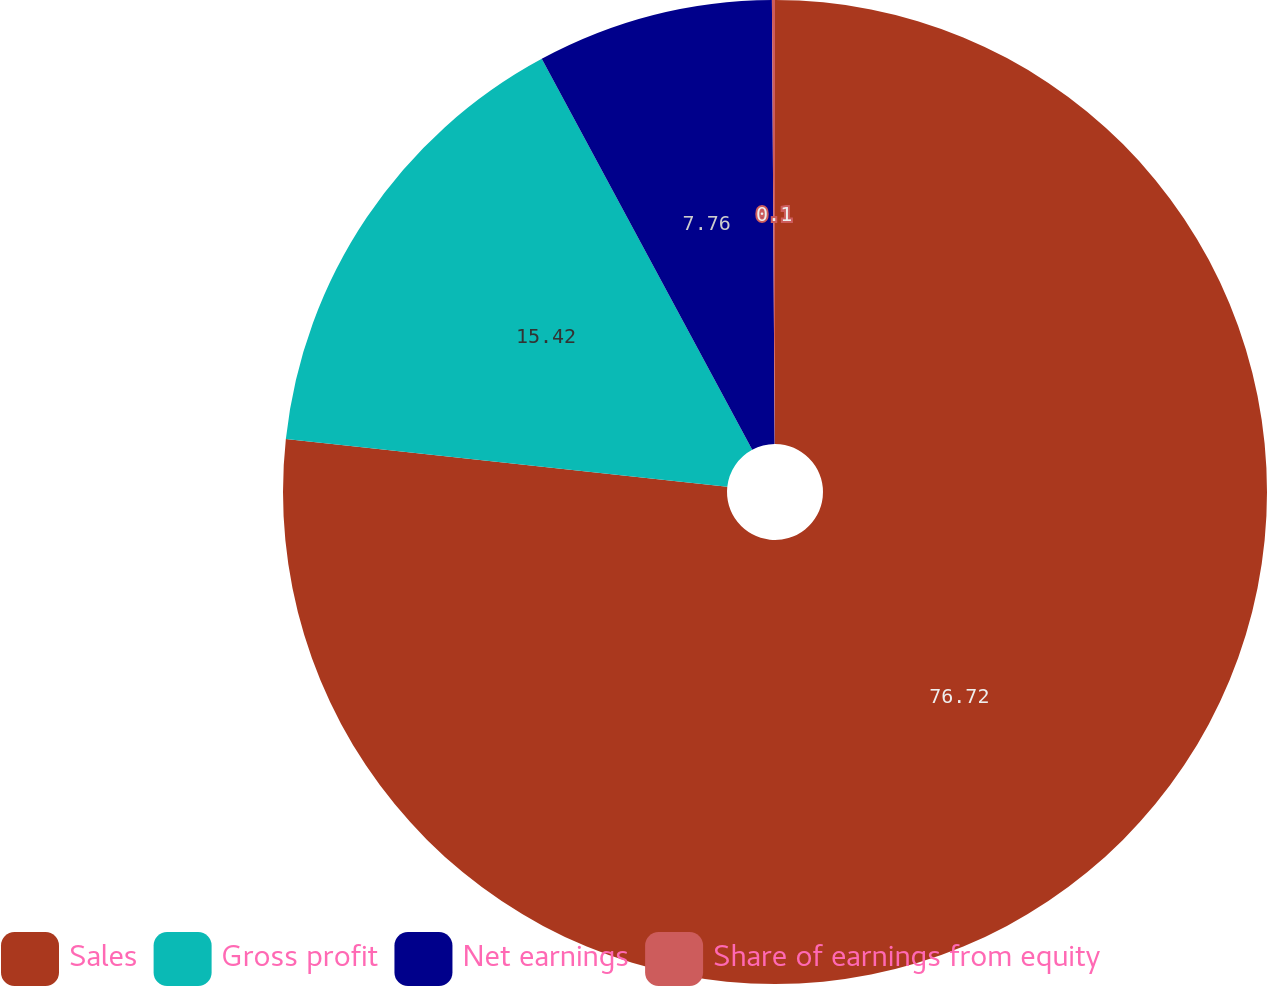Convert chart. <chart><loc_0><loc_0><loc_500><loc_500><pie_chart><fcel>Sales<fcel>Gross profit<fcel>Net earnings<fcel>Share of earnings from equity<nl><fcel>76.71%<fcel>15.42%<fcel>7.76%<fcel>0.1%<nl></chart> 